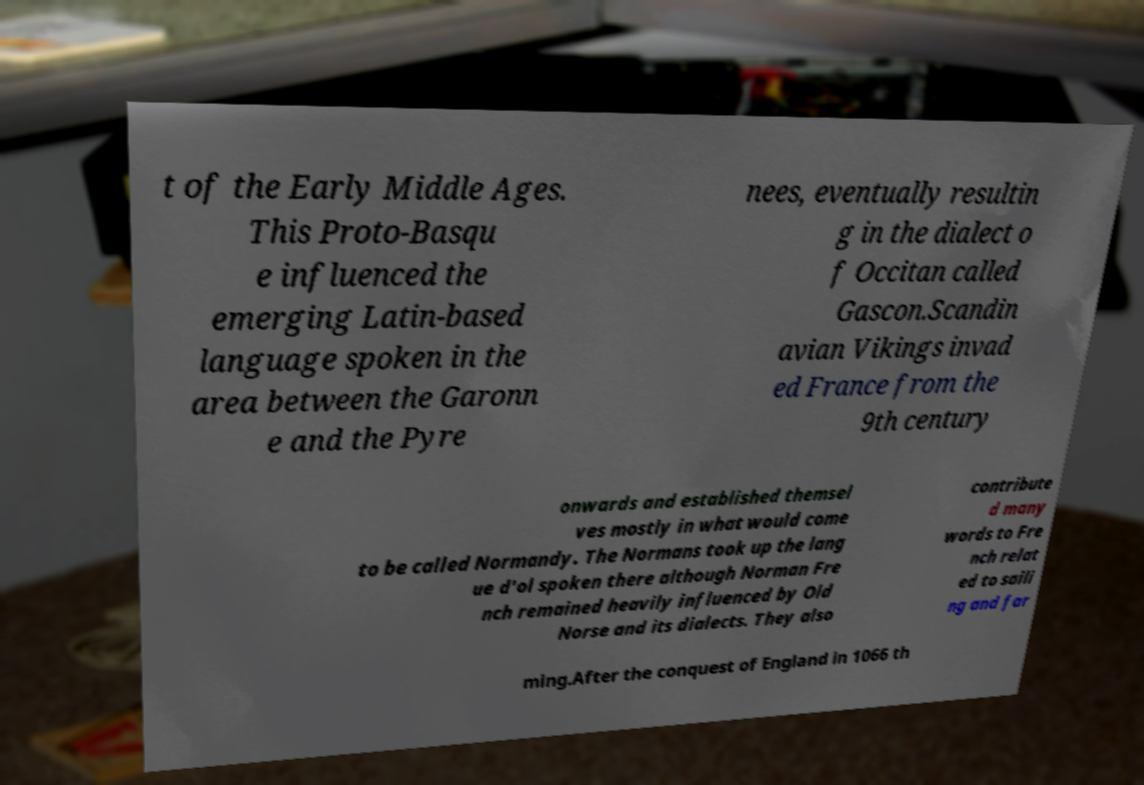Please read and relay the text visible in this image. What does it say? t of the Early Middle Ages. This Proto-Basqu e influenced the emerging Latin-based language spoken in the area between the Garonn e and the Pyre nees, eventually resultin g in the dialect o f Occitan called Gascon.Scandin avian Vikings invad ed France from the 9th century onwards and established themsel ves mostly in what would come to be called Normandy. The Normans took up the lang ue d'ol spoken there although Norman Fre nch remained heavily influenced by Old Norse and its dialects. They also contribute d many words to Fre nch relat ed to saili ng and far ming.After the conquest of England in 1066 th 